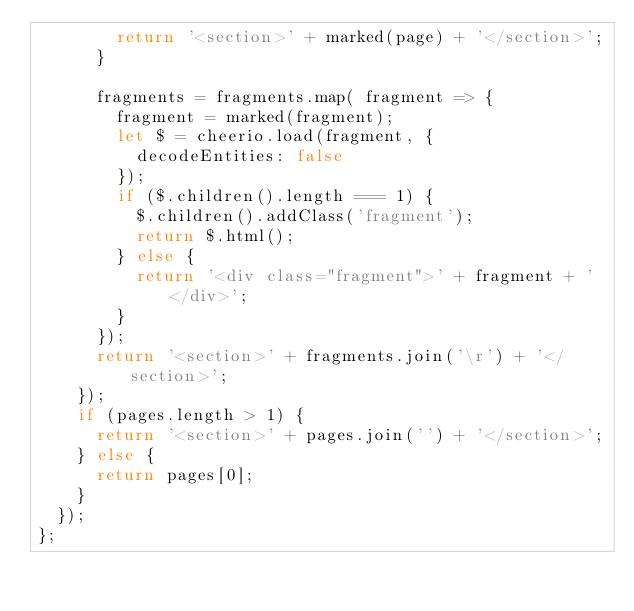<code> <loc_0><loc_0><loc_500><loc_500><_JavaScript_>        return '<section>' + marked(page) + '</section>';
      }

      fragments = fragments.map( fragment => {
        fragment = marked(fragment);
        let $ = cheerio.load(fragment, {
          decodeEntities: false
        });
        if ($.children().length === 1) {
          $.children().addClass('fragment');
          return $.html();
        } else {
          return '<div class="fragment">' + fragment + '</div>';
        }
      });
      return '<section>' + fragments.join('\r') + '</section>';
    });
    if (pages.length > 1) {
      return '<section>' + pages.join('') + '</section>';
    } else {
      return pages[0];
    }
  });
};</code> 